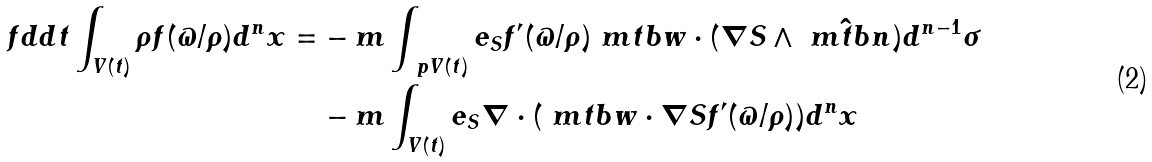Convert formula to latex. <formula><loc_0><loc_0><loc_500><loc_500>\ f { d } { d t } \int _ { V ( t ) } \rho f ( \varpi / \rho ) d ^ { n } x = & - m \int _ { \ p V ( t ) } e _ { S } f ^ { \prime } ( \varpi / \rho ) \ m t b { w } \cdot ( \nabla S \wedge \hat { \ m t b { n } } ) d ^ { n - 1 } \sigma \\ & - m \int _ { V ( t ) } e _ { S } \nabla \cdot ( \ m t b { w } \cdot \nabla S f ^ { \prime } ( \varpi / \rho ) ) d ^ { n } x</formula> 